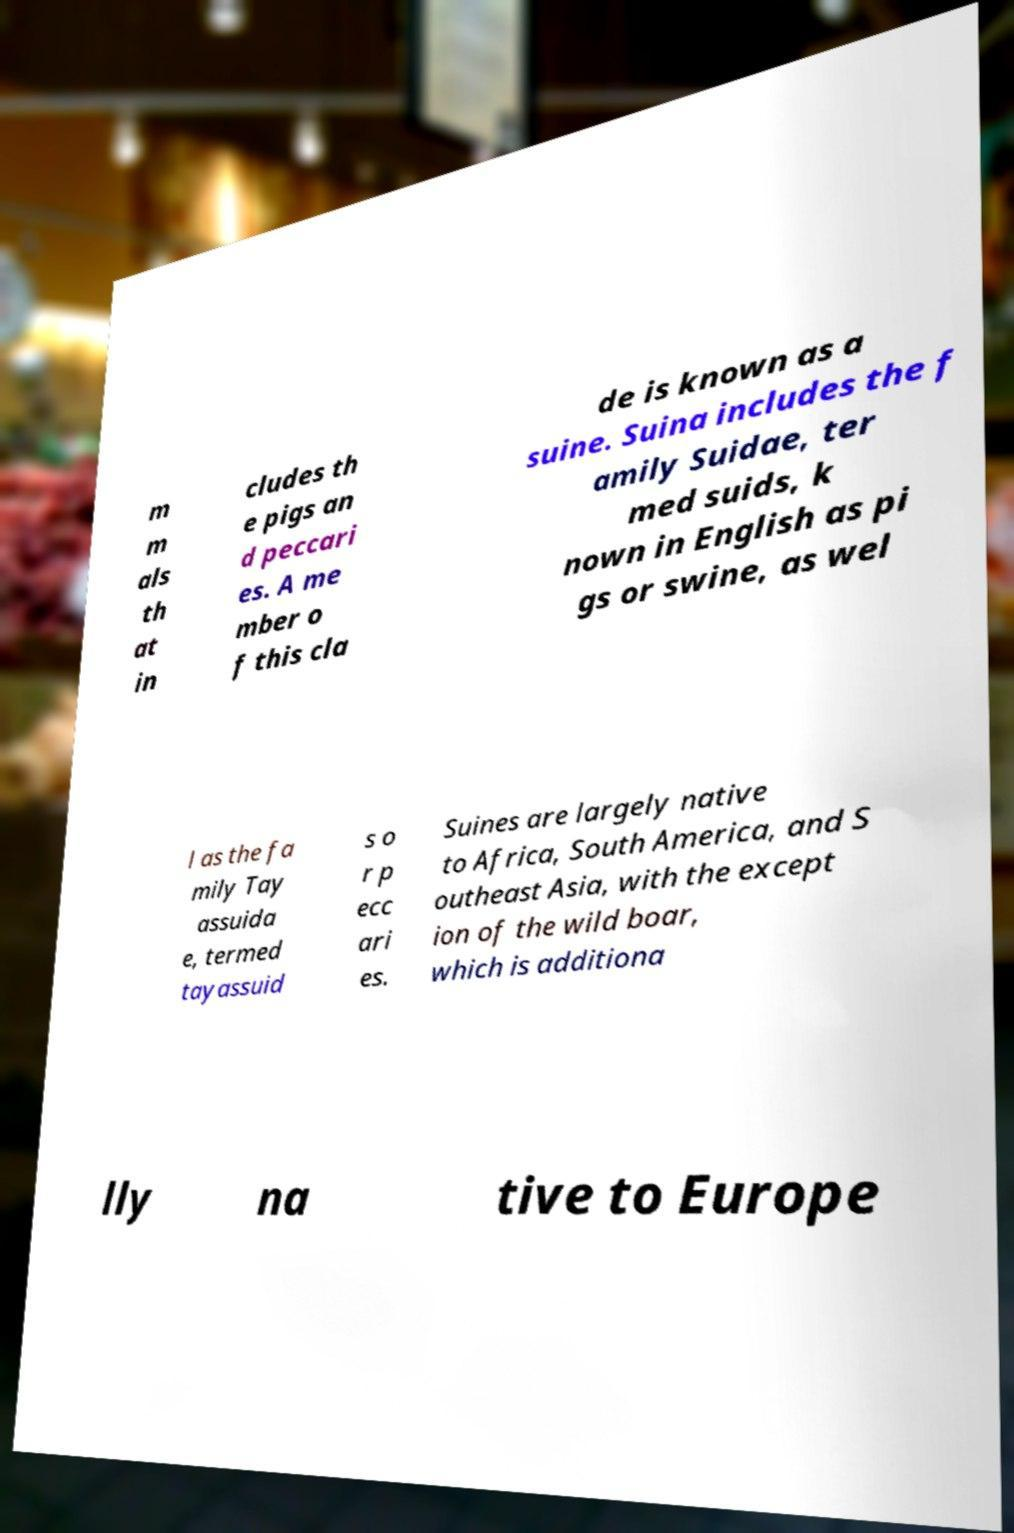I need the written content from this picture converted into text. Can you do that? m m als th at in cludes th e pigs an d peccari es. A me mber o f this cla de is known as a suine. Suina includes the f amily Suidae, ter med suids, k nown in English as pi gs or swine, as wel l as the fa mily Tay assuida e, termed tayassuid s o r p ecc ari es. Suines are largely native to Africa, South America, and S outheast Asia, with the except ion of the wild boar, which is additiona lly na tive to Europe 